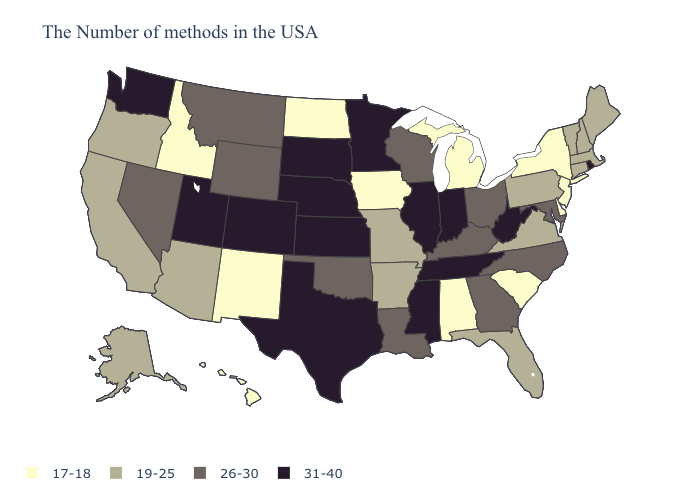Name the states that have a value in the range 19-25?
Be succinct. Maine, Massachusetts, New Hampshire, Vermont, Connecticut, Pennsylvania, Virginia, Florida, Missouri, Arkansas, Arizona, California, Oregon, Alaska. Among the states that border Pennsylvania , which have the lowest value?
Quick response, please. New York, New Jersey, Delaware. What is the lowest value in states that border Florida?
Concise answer only. 17-18. What is the value of Ohio?
Answer briefly. 26-30. Which states have the lowest value in the USA?
Keep it brief. New York, New Jersey, Delaware, South Carolina, Michigan, Alabama, Iowa, North Dakota, New Mexico, Idaho, Hawaii. Name the states that have a value in the range 19-25?
Short answer required. Maine, Massachusetts, New Hampshire, Vermont, Connecticut, Pennsylvania, Virginia, Florida, Missouri, Arkansas, Arizona, California, Oregon, Alaska. What is the value of North Dakota?
Give a very brief answer. 17-18. What is the lowest value in the West?
Give a very brief answer. 17-18. What is the value of Kentucky?
Keep it brief. 26-30. What is the value of Arizona?
Write a very short answer. 19-25. Name the states that have a value in the range 26-30?
Quick response, please. Maryland, North Carolina, Ohio, Georgia, Kentucky, Wisconsin, Louisiana, Oklahoma, Wyoming, Montana, Nevada. Does New Hampshire have a higher value than New York?
Answer briefly. Yes. Does North Dakota have the lowest value in the MidWest?
Keep it brief. Yes. Name the states that have a value in the range 19-25?
Write a very short answer. Maine, Massachusetts, New Hampshire, Vermont, Connecticut, Pennsylvania, Virginia, Florida, Missouri, Arkansas, Arizona, California, Oregon, Alaska. Among the states that border Nevada , which have the highest value?
Write a very short answer. Utah. 